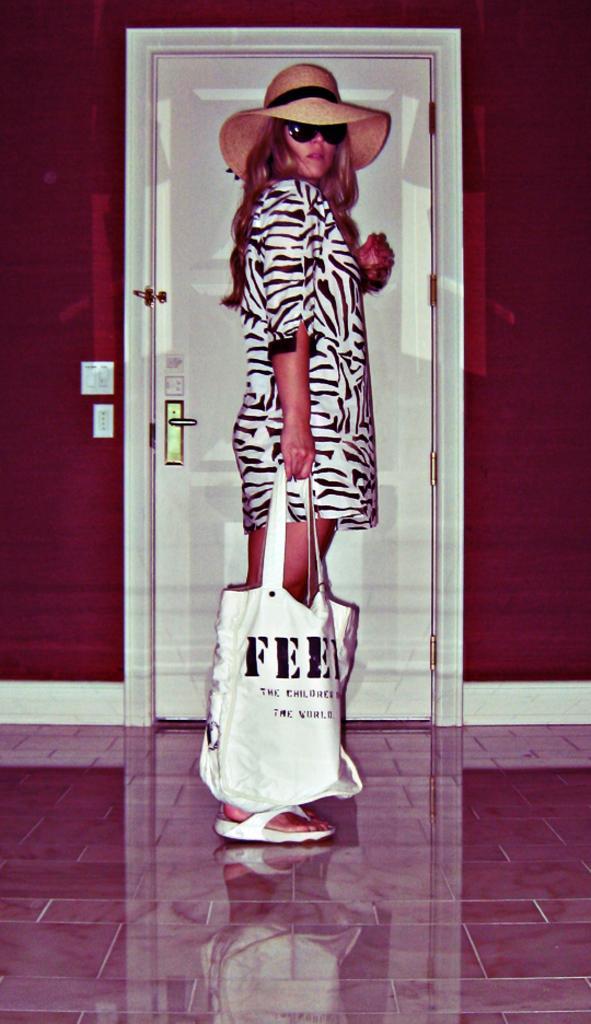In one or two sentences, can you explain what this image depicts? Here is a woman standing,she is holding white bag in her hand. She wore white dress with black stripes,a hat and goggles. At background I can see a door with the door handle. This looks like a switch board attached to the wall. The door id of white in color. 